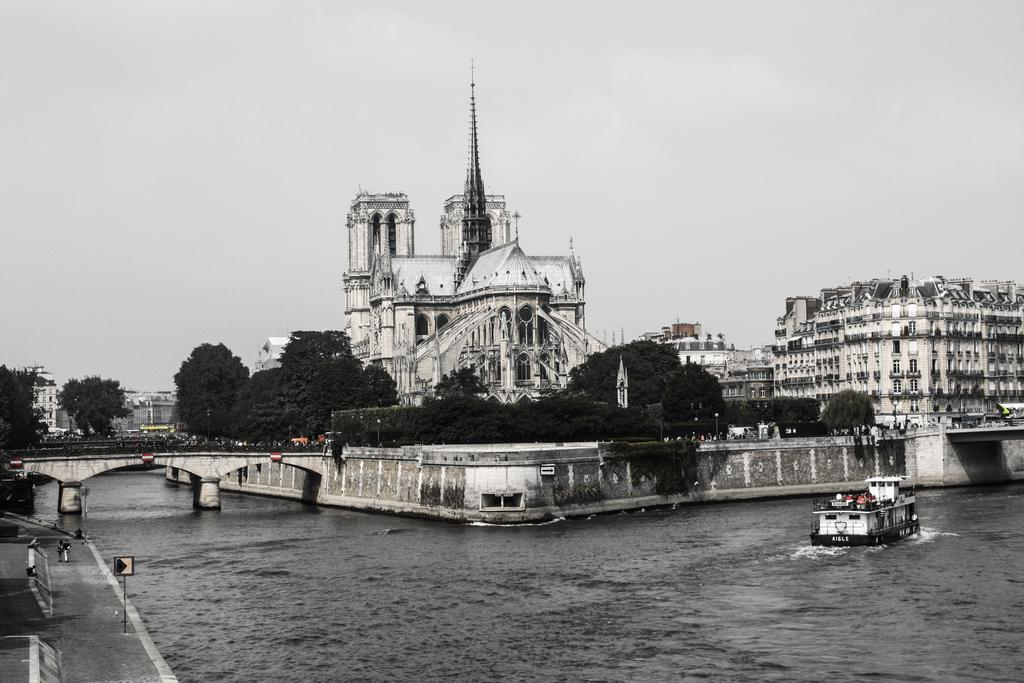What type of structures can be seen in the image? There are buildings in the image. What other natural elements are present in the image? There are trees in the image. What type of man-made structure connects two areas in the image? There is a bridge in the image. What type of vehicle is present in the water in the image? There is a ship in the water in the image. What is visible at the top of the image? The sky is visible at the top of the image. What type of cup can be seen on the bridge in the image? There is no cup present on the bridge in the image. What type of dirt is visible on the buildings in the image? There is no dirt visible on the buildings in the image. 